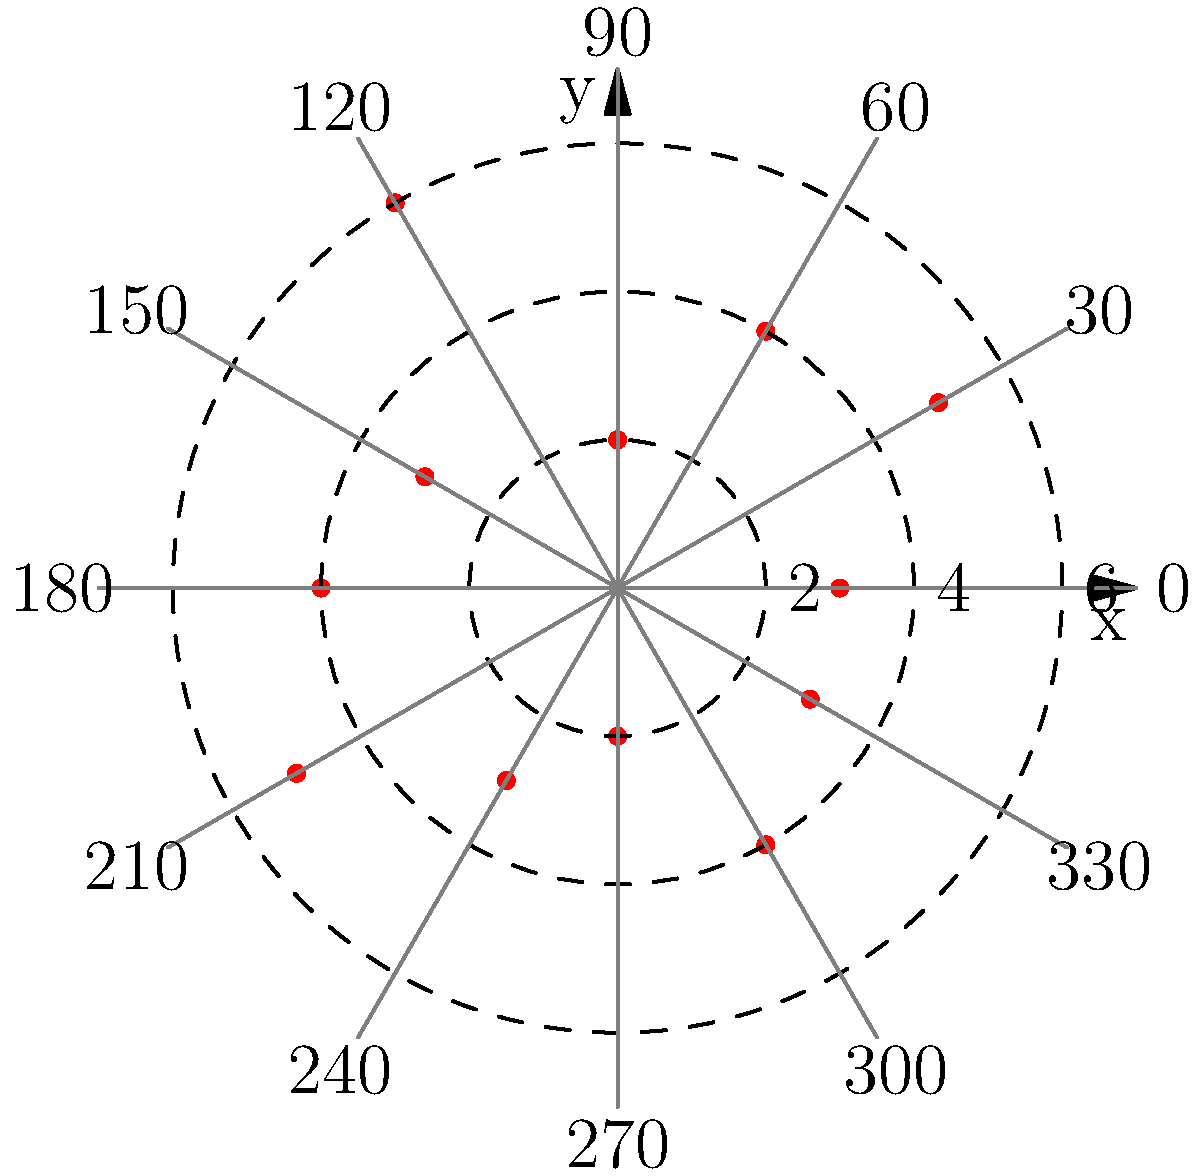Based on the polar graph showing multiple paparazzi sightings around a celebrity's location, what is the most likely direction (in degrees) from which the paparazzi are operating, and at what approximate distance (in units) from the celebrity's location? To determine the most likely direction and distance of paparazzi operations, we need to analyze the pattern of sightings on the polar graph:

1. Examine the distribution of points:
   - The points represent individual paparazzi sightings.
   - Their position indicates direction (angle) and distance from the celebrity's location (center of the graph).

2. Identify clusters or concentrations:
   - Look for areas where multiple points are grouped closely together.
   - The largest cluster appears to be in the upper-right quadrant of the graph.

3. Determine the angle:
   - The cluster is centered around the 120° mark on the graph.
   - This suggests the paparazzi are most frequently spotted at approximately 120° from the celebrity's location.

4. Estimate the distance:
   - The points in the cluster are mostly between the 4 and 6 unit circles.
   - The average distance appears to be around 5 units from the center.

5. Conclude:
   - The most likely direction is 120°.
   - The approximate distance is 5 units.

This analysis suggests that the paparazzi are primarily operating from a location about 5 units away from the celebrity, at an angle of 120° (which is in the southeast direction if we consider 0° as east).
Answer: 120°, 5 units 